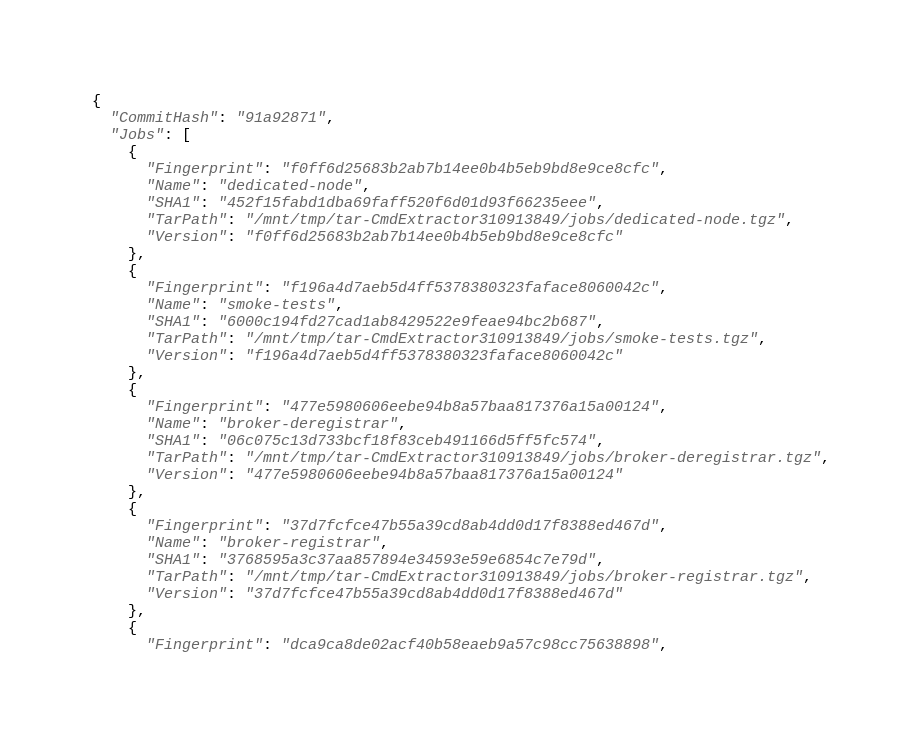<code> <loc_0><loc_0><loc_500><loc_500><_YAML_>{
  "CommitHash": "91a92871",
  "Jobs": [
    {
      "Fingerprint": "f0ff6d25683b2ab7b14ee0b4b5eb9bd8e9ce8cfc",
      "Name": "dedicated-node",
      "SHA1": "452f15fabd1dba69faff520f6d01d93f66235eee",
      "TarPath": "/mnt/tmp/tar-CmdExtractor310913849/jobs/dedicated-node.tgz",
      "Version": "f0ff6d25683b2ab7b14ee0b4b5eb9bd8e9ce8cfc"
    },
    {
      "Fingerprint": "f196a4d7aeb5d4ff5378380323faface8060042c",
      "Name": "smoke-tests",
      "SHA1": "6000c194fd27cad1ab8429522e9feae94bc2b687",
      "TarPath": "/mnt/tmp/tar-CmdExtractor310913849/jobs/smoke-tests.tgz",
      "Version": "f196a4d7aeb5d4ff5378380323faface8060042c"
    },
    {
      "Fingerprint": "477e5980606eebe94b8a57baa817376a15a00124",
      "Name": "broker-deregistrar",
      "SHA1": "06c075c13d733bcf18f83ceb491166d5ff5fc574",
      "TarPath": "/mnt/tmp/tar-CmdExtractor310913849/jobs/broker-deregistrar.tgz",
      "Version": "477e5980606eebe94b8a57baa817376a15a00124"
    },
    {
      "Fingerprint": "37d7fcfce47b55a39cd8ab4dd0d17f8388ed467d",
      "Name": "broker-registrar",
      "SHA1": "3768595a3c37aa857894e34593e59e6854c7e79d",
      "TarPath": "/mnt/tmp/tar-CmdExtractor310913849/jobs/broker-registrar.tgz",
      "Version": "37d7fcfce47b55a39cd8ab4dd0d17f8388ed467d"
    },
    {
      "Fingerprint": "dca9ca8de02acf40b58eaeb9a57c98cc75638898",</code> 